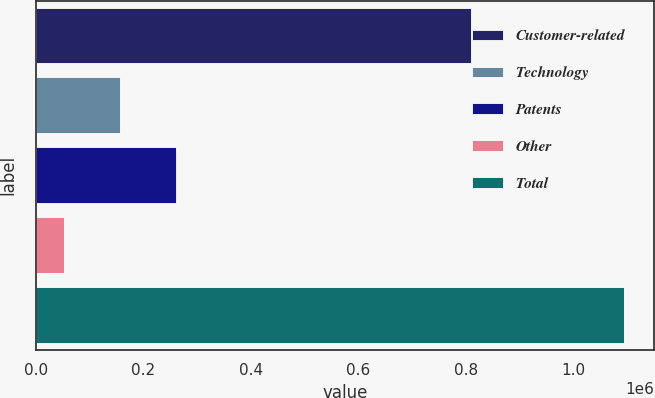<chart> <loc_0><loc_0><loc_500><loc_500><bar_chart><fcel>Customer-related<fcel>Technology<fcel>Patents<fcel>Other<fcel>Total<nl><fcel>809683<fcel>156670<fcel>260998<fcel>52342<fcel>1.09562e+06<nl></chart> 